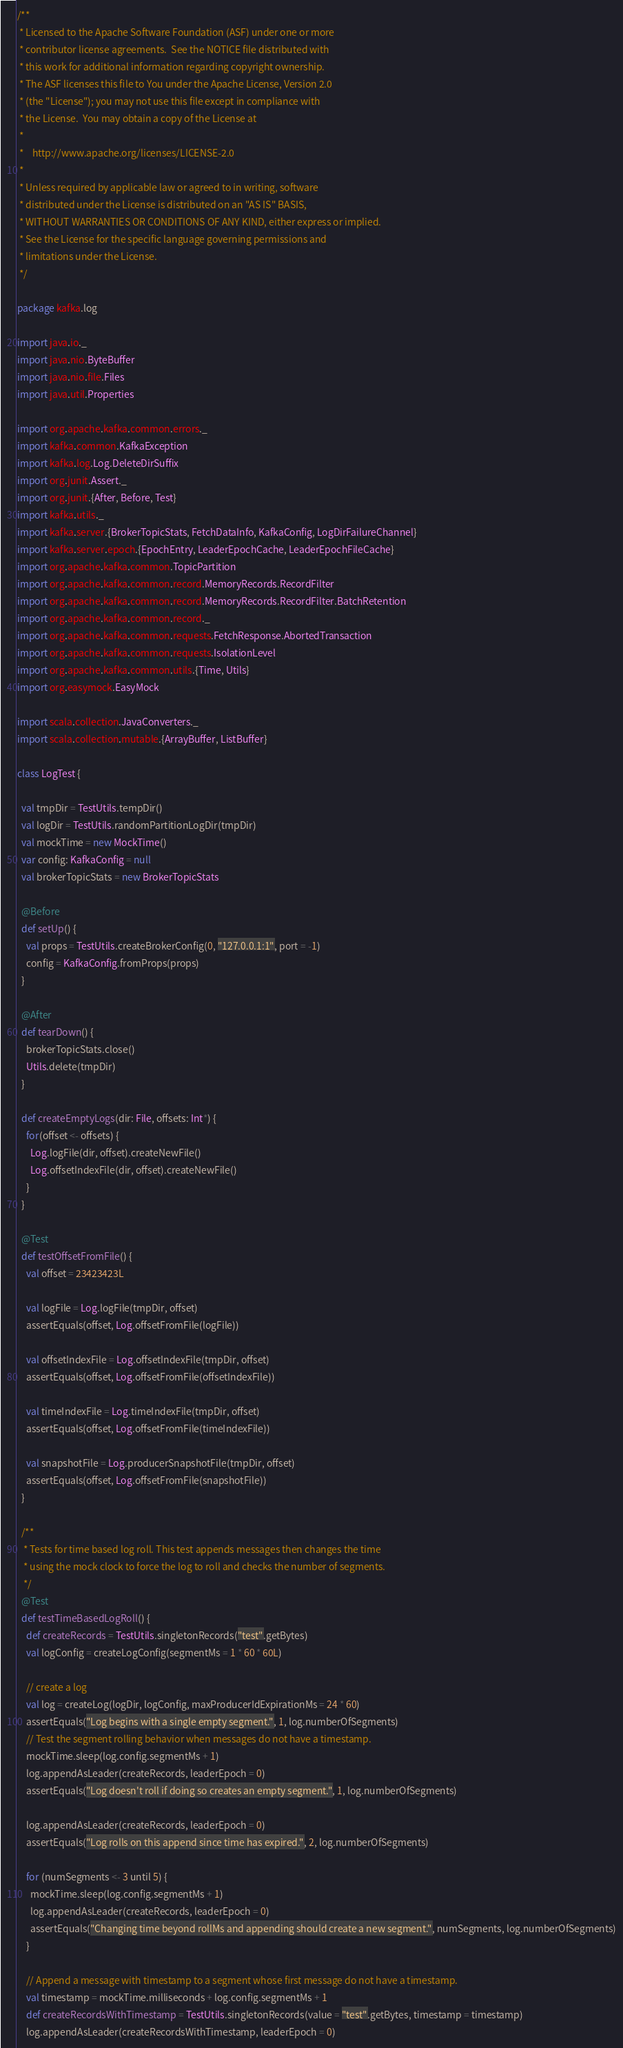Convert code to text. <code><loc_0><loc_0><loc_500><loc_500><_Scala_>/**
 * Licensed to the Apache Software Foundation (ASF) under one or more
 * contributor license agreements.  See the NOTICE file distributed with
 * this work for additional information regarding copyright ownership.
 * The ASF licenses this file to You under the Apache License, Version 2.0
 * (the "License"); you may not use this file except in compliance with
 * the License.  You may obtain a copy of the License at
 *
 *    http://www.apache.org/licenses/LICENSE-2.0
 *
 * Unless required by applicable law or agreed to in writing, software
 * distributed under the License is distributed on an "AS IS" BASIS,
 * WITHOUT WARRANTIES OR CONDITIONS OF ANY KIND, either express or implied.
 * See the License for the specific language governing permissions and
 * limitations under the License.
 */

package kafka.log

import java.io._
import java.nio.ByteBuffer
import java.nio.file.Files
import java.util.Properties

import org.apache.kafka.common.errors._
import kafka.common.KafkaException
import kafka.log.Log.DeleteDirSuffix
import org.junit.Assert._
import org.junit.{After, Before, Test}
import kafka.utils._
import kafka.server.{BrokerTopicStats, FetchDataInfo, KafkaConfig, LogDirFailureChannel}
import kafka.server.epoch.{EpochEntry, LeaderEpochCache, LeaderEpochFileCache}
import org.apache.kafka.common.TopicPartition
import org.apache.kafka.common.record.MemoryRecords.RecordFilter
import org.apache.kafka.common.record.MemoryRecords.RecordFilter.BatchRetention
import org.apache.kafka.common.record._
import org.apache.kafka.common.requests.FetchResponse.AbortedTransaction
import org.apache.kafka.common.requests.IsolationLevel
import org.apache.kafka.common.utils.{Time, Utils}
import org.easymock.EasyMock

import scala.collection.JavaConverters._
import scala.collection.mutable.{ArrayBuffer, ListBuffer}

class LogTest {

  val tmpDir = TestUtils.tempDir()
  val logDir = TestUtils.randomPartitionLogDir(tmpDir)
  val mockTime = new MockTime()
  var config: KafkaConfig = null
  val brokerTopicStats = new BrokerTopicStats

  @Before
  def setUp() {
    val props = TestUtils.createBrokerConfig(0, "127.0.0.1:1", port = -1)
    config = KafkaConfig.fromProps(props)
  }

  @After
  def tearDown() {
    brokerTopicStats.close()
    Utils.delete(tmpDir)
  }

  def createEmptyLogs(dir: File, offsets: Int*) {
    for(offset <- offsets) {
      Log.logFile(dir, offset).createNewFile()
      Log.offsetIndexFile(dir, offset).createNewFile()
    }
  }

  @Test
  def testOffsetFromFile() {
    val offset = 23423423L

    val logFile = Log.logFile(tmpDir, offset)
    assertEquals(offset, Log.offsetFromFile(logFile))

    val offsetIndexFile = Log.offsetIndexFile(tmpDir, offset)
    assertEquals(offset, Log.offsetFromFile(offsetIndexFile))

    val timeIndexFile = Log.timeIndexFile(tmpDir, offset)
    assertEquals(offset, Log.offsetFromFile(timeIndexFile))

    val snapshotFile = Log.producerSnapshotFile(tmpDir, offset)
    assertEquals(offset, Log.offsetFromFile(snapshotFile))
  }

  /**
   * Tests for time based log roll. This test appends messages then changes the time
   * using the mock clock to force the log to roll and checks the number of segments.
   */
  @Test
  def testTimeBasedLogRoll() {
    def createRecords = TestUtils.singletonRecords("test".getBytes)
    val logConfig = createLogConfig(segmentMs = 1 * 60 * 60L)

    // create a log
    val log = createLog(logDir, logConfig, maxProducerIdExpirationMs = 24 * 60)
    assertEquals("Log begins with a single empty segment.", 1, log.numberOfSegments)
    // Test the segment rolling behavior when messages do not have a timestamp.
    mockTime.sleep(log.config.segmentMs + 1)
    log.appendAsLeader(createRecords, leaderEpoch = 0)
    assertEquals("Log doesn't roll if doing so creates an empty segment.", 1, log.numberOfSegments)

    log.appendAsLeader(createRecords, leaderEpoch = 0)
    assertEquals("Log rolls on this append since time has expired.", 2, log.numberOfSegments)

    for (numSegments <- 3 until 5) {
      mockTime.sleep(log.config.segmentMs + 1)
      log.appendAsLeader(createRecords, leaderEpoch = 0)
      assertEquals("Changing time beyond rollMs and appending should create a new segment.", numSegments, log.numberOfSegments)
    }

    // Append a message with timestamp to a segment whose first message do not have a timestamp.
    val timestamp = mockTime.milliseconds + log.config.segmentMs + 1
    def createRecordsWithTimestamp = TestUtils.singletonRecords(value = "test".getBytes, timestamp = timestamp)
    log.appendAsLeader(createRecordsWithTimestamp, leaderEpoch = 0)</code> 